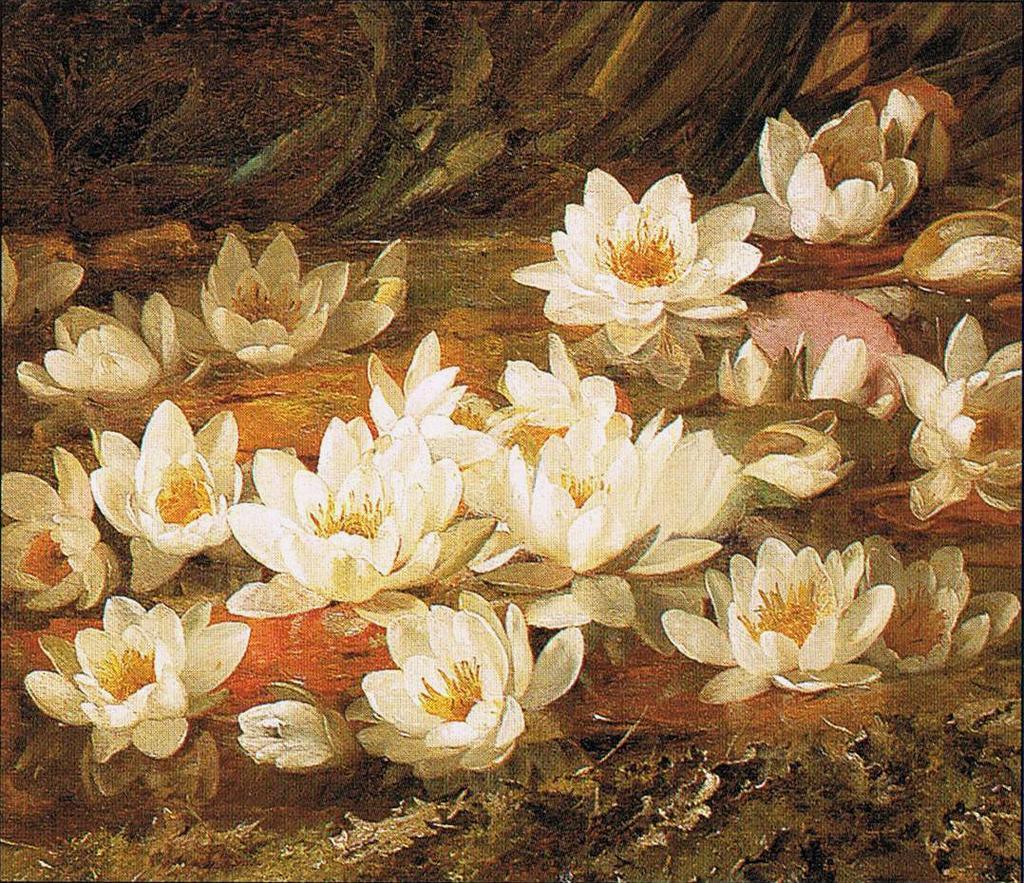How would you summarize this image in a sentence or two? We can see flowers and water. Background it is blur. 